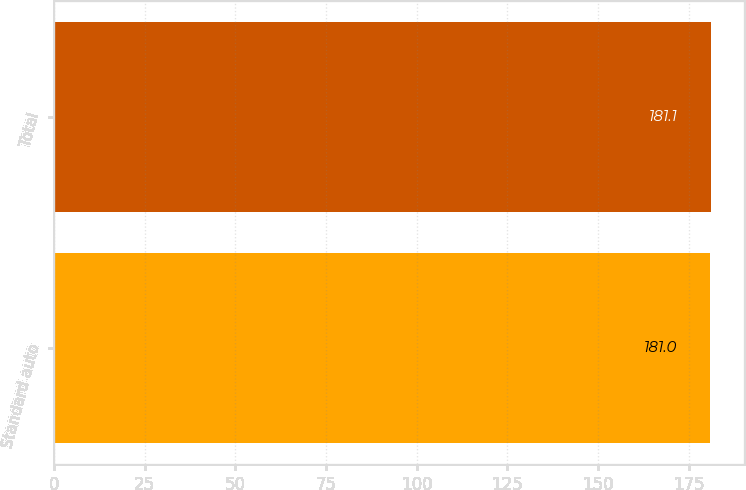Convert chart. <chart><loc_0><loc_0><loc_500><loc_500><bar_chart><fcel>Standard auto<fcel>Total<nl><fcel>181<fcel>181.1<nl></chart> 